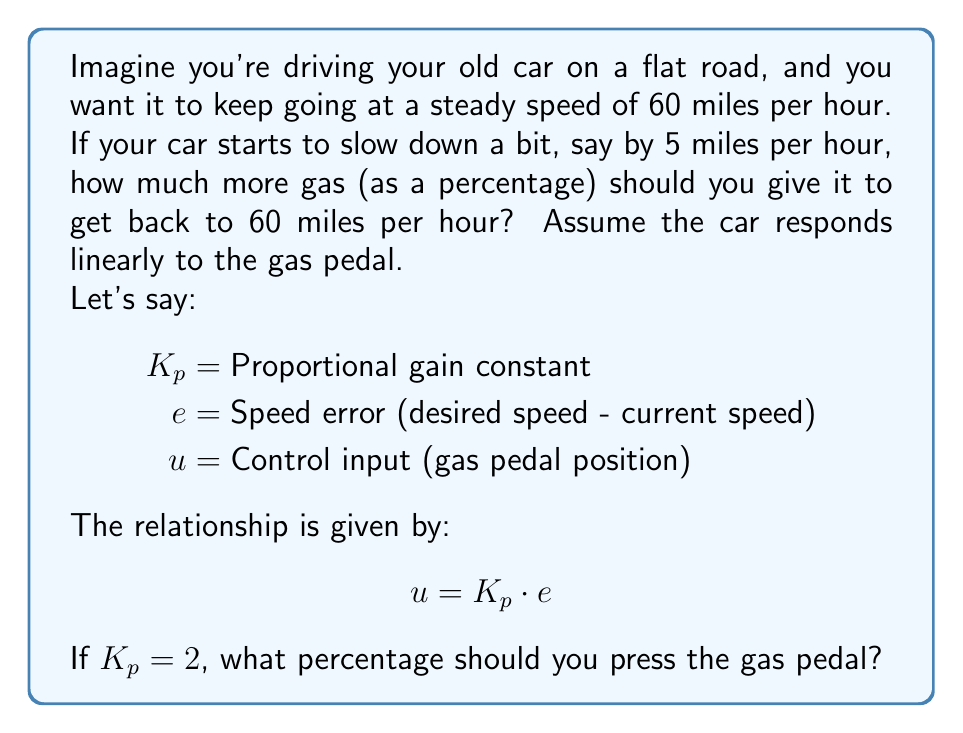Provide a solution to this math problem. Let's break this down step-by-step:

1. First, we need to understand what the question is asking. We want to find out how much to press the gas pedal when the car slows down by 5 miles per hour.

2. We're given a simple equation: $u = K_p \cdot e$
   - $u$ is how much we press the gas pedal
   - $K_p$ is a number that tells us how strongly the car responds to the gas pedal
   - $e$ is the difference between how fast we want to go and how fast we're actually going

3. We know:
   - $K_p = 2$ (given in the question)
   - Desired speed = 60 mph
   - Current speed = 55 mph (because it slowed down by 5 mph)

4. Let's calculate $e$:
   $e = \text{Desired speed} - \text{Current speed}$
   $e = 60 - 55 = 5$ mph

5. Now we can use our equation:
   $u = K_p \cdot e$
   $u = 2 \cdot 5 = 10$

6. This means we need to press the gas pedal 10 units more. But the question asks for a percentage.

7. In control systems, we often consider 0% as no gas and 100% as full gas. So, 10 units out of 100 is the same as 10%.
Answer: You should press the gas pedal 10% more to return to the desired speed of 60 miles per hour. 